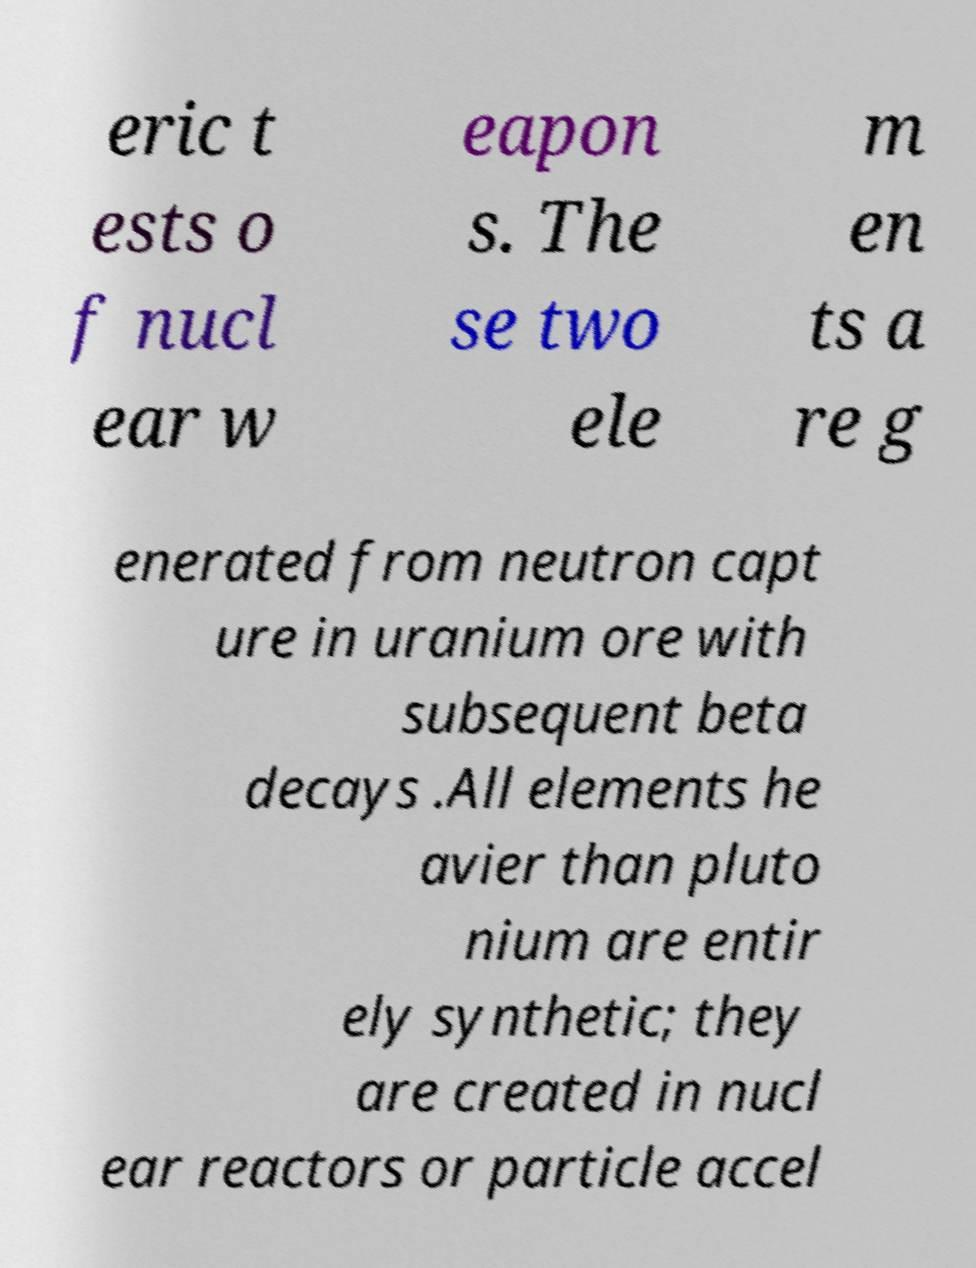For documentation purposes, I need the text within this image transcribed. Could you provide that? eric t ests o f nucl ear w eapon s. The se two ele m en ts a re g enerated from neutron capt ure in uranium ore with subsequent beta decays .All elements he avier than pluto nium are entir ely synthetic; they are created in nucl ear reactors or particle accel 